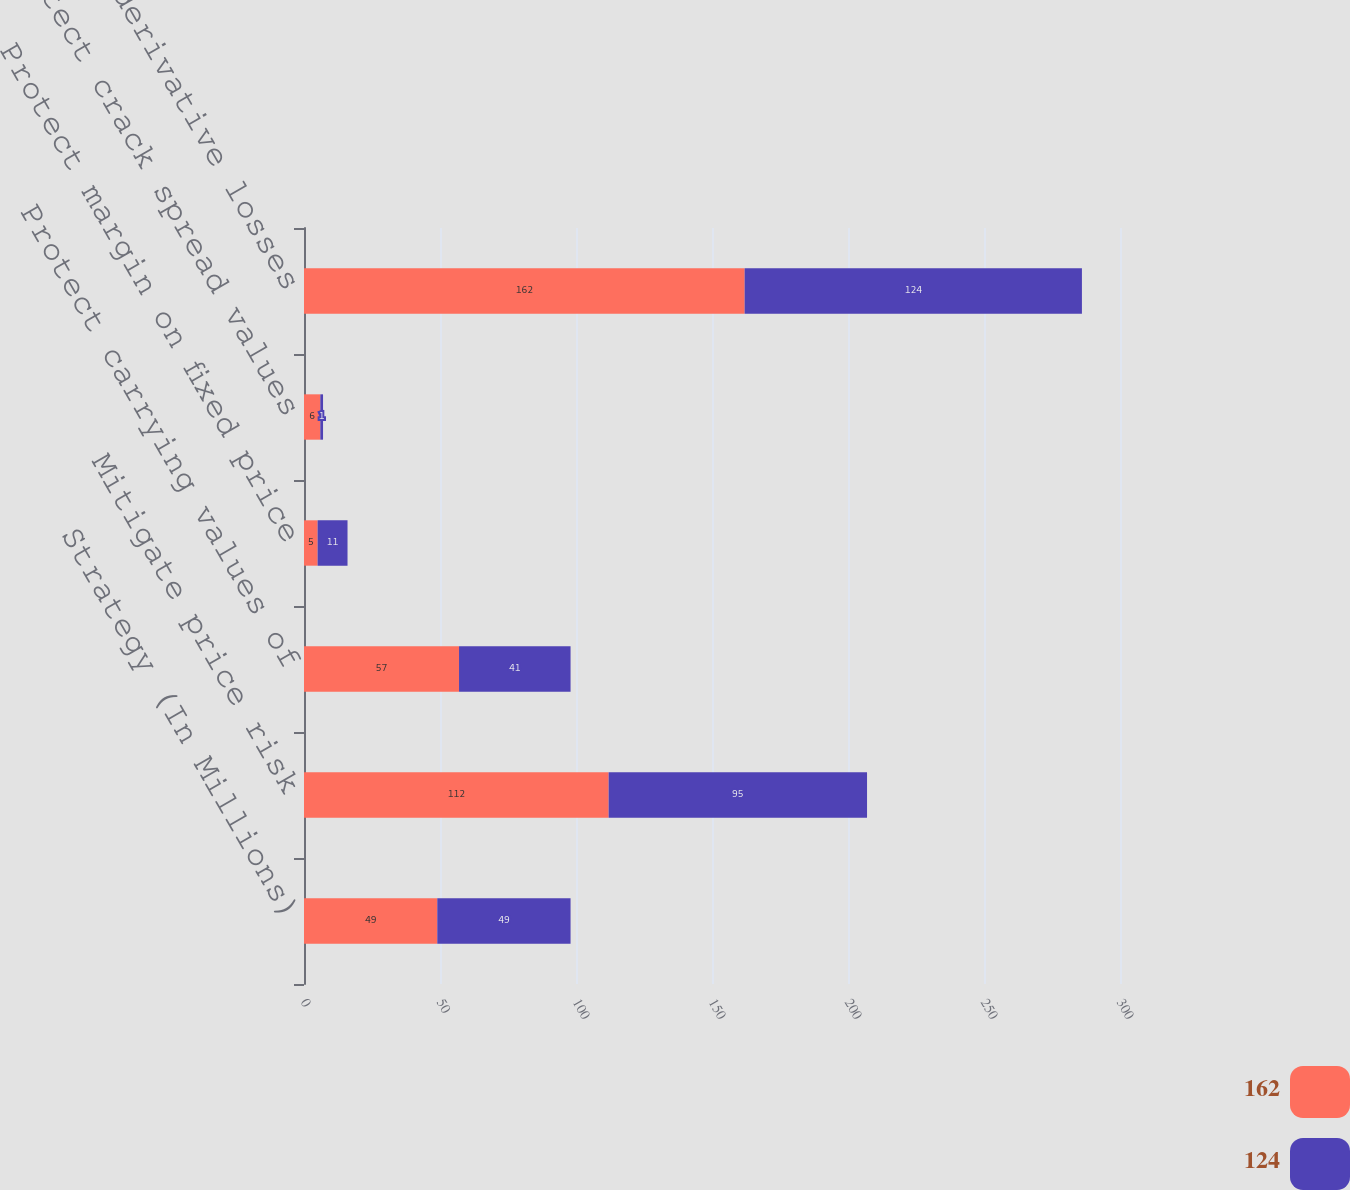<chart> <loc_0><loc_0><loc_500><loc_500><stacked_bar_chart><ecel><fcel>Strategy (In Millions)<fcel>Mitigate price risk<fcel>Protect carrying values of<fcel>Protect margin on fixed price<fcel>Protect crack spread values<fcel>Total net derivative losses<nl><fcel>162<fcel>49<fcel>112<fcel>57<fcel>5<fcel>6<fcel>162<nl><fcel>124<fcel>49<fcel>95<fcel>41<fcel>11<fcel>1<fcel>124<nl></chart> 